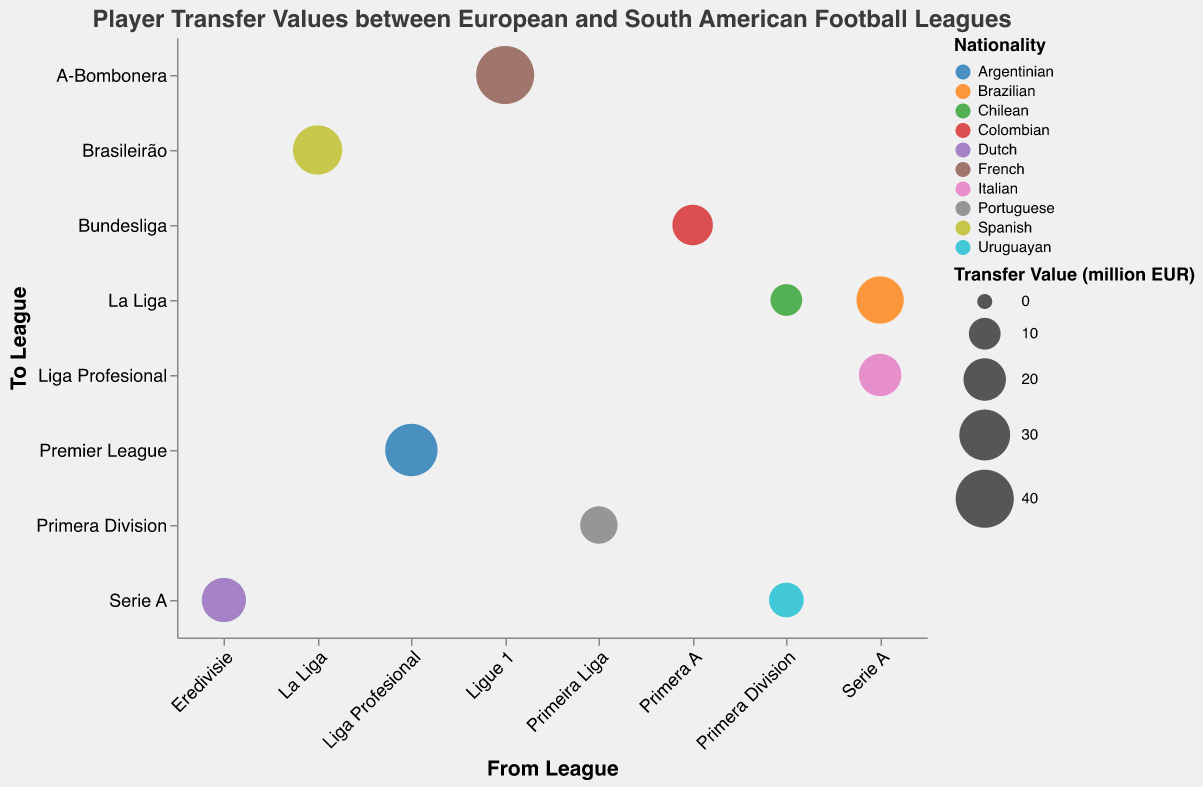Which nationality has the highest transfer value in the 18-24 age group? In the 18-24 age group, look for the biggest bubble sizes and their "Nationality" labels. The French player has the highest transfer value of 40 million EUR.
Answer: French Which transfer involves an Italian player and what's its value? Find a bubble labeled "Italian" and then check its transfer value. The Italian player's transfer is valued at 20 million EUR, moving from Serie A to Liga Profesional.
Answer: 20 million EUR How many players are transferred from European leagues to South American leagues? Check the "From League" and "To League" columns to identify the leagues, and count the bubbles showing transfers from Europe to South America. Only the Spanish player is transferred from La Liga to Brasileirão.
Answer: 1 What's the difference in transfer values between the lowest and highest in the 25-30 age group? Identify the bubbles in the 25-30 age group, note their transfer values, and compute the difference. The highest is the Argentinian player at 32 million EUR, and the lowest is the Uruguayan player at 12.5 million EUR. The difference is 32 - 12.5 = 19.5 million EUR.
Answer: 19.5 million EUR Which player transfer has the smallest value, and where is the player from? Look for the smallest bubble and check its "Nationality" and "Transfer Value". The Chilean player has the smallest transfer value of 10 million EUR, moving from Primera Division to La Liga.
Answer: Chilean, 10 million EUR From which league are most 18-24-year-old players transferred? Identify the "From League" for all bubbles in the 18-24 age group and count occurrences to find Serie A, Ligue 1, Primera A, and Primera Division. Each has 1 player. Since there’s no clear “most”, any of these leagues is a valid answer.
Answer: Serie A, Ligue 1, Primera A, Primera Division How many nationalities are represented in player transfers? Count the distinct "Nationalities" in the data. There are Brazilian, Argentinian, French, Uruguayan, Portuguese, Italian, Colombian, Spanish, Chilean, and Dutch, making 10 in total.
Answer: 10 Which league pairs have the same number of transfers for both age groups? Examine the x-y axis pairs and count entries in each age group (18-24 and 25-30). The pairs Serie A to La Liga and Serie A to Serie A have similar counts.
Answer: No pairs Which transfer values are above 25 million EUR? Identify all bubbles with transfer values greater than 25 million EUR. These are the Brazilian (25.5 million EUR), Argentinian (32 million EUR), French (40 million EUR), and Spanish (28 million EUR).
Answer: Brazilian, Argentinian, French, Spanish Which nationality's players are transferred to the most different leagues? Track the "To League" for each nationality group. Spanish players move to Brasileirão, Italians to Liga Profesional, the Dutch to Serie A, and so forth. Each nationality is transferred to one other league only.
Answer: None 